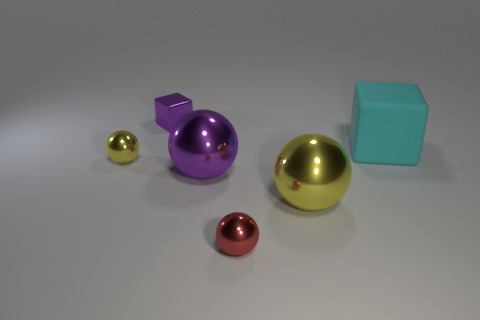Which object in the image appears to be the heaviest? Based on their relative size and assuming standard densities, the golden sphere looks to be the heaviest object in the image. 